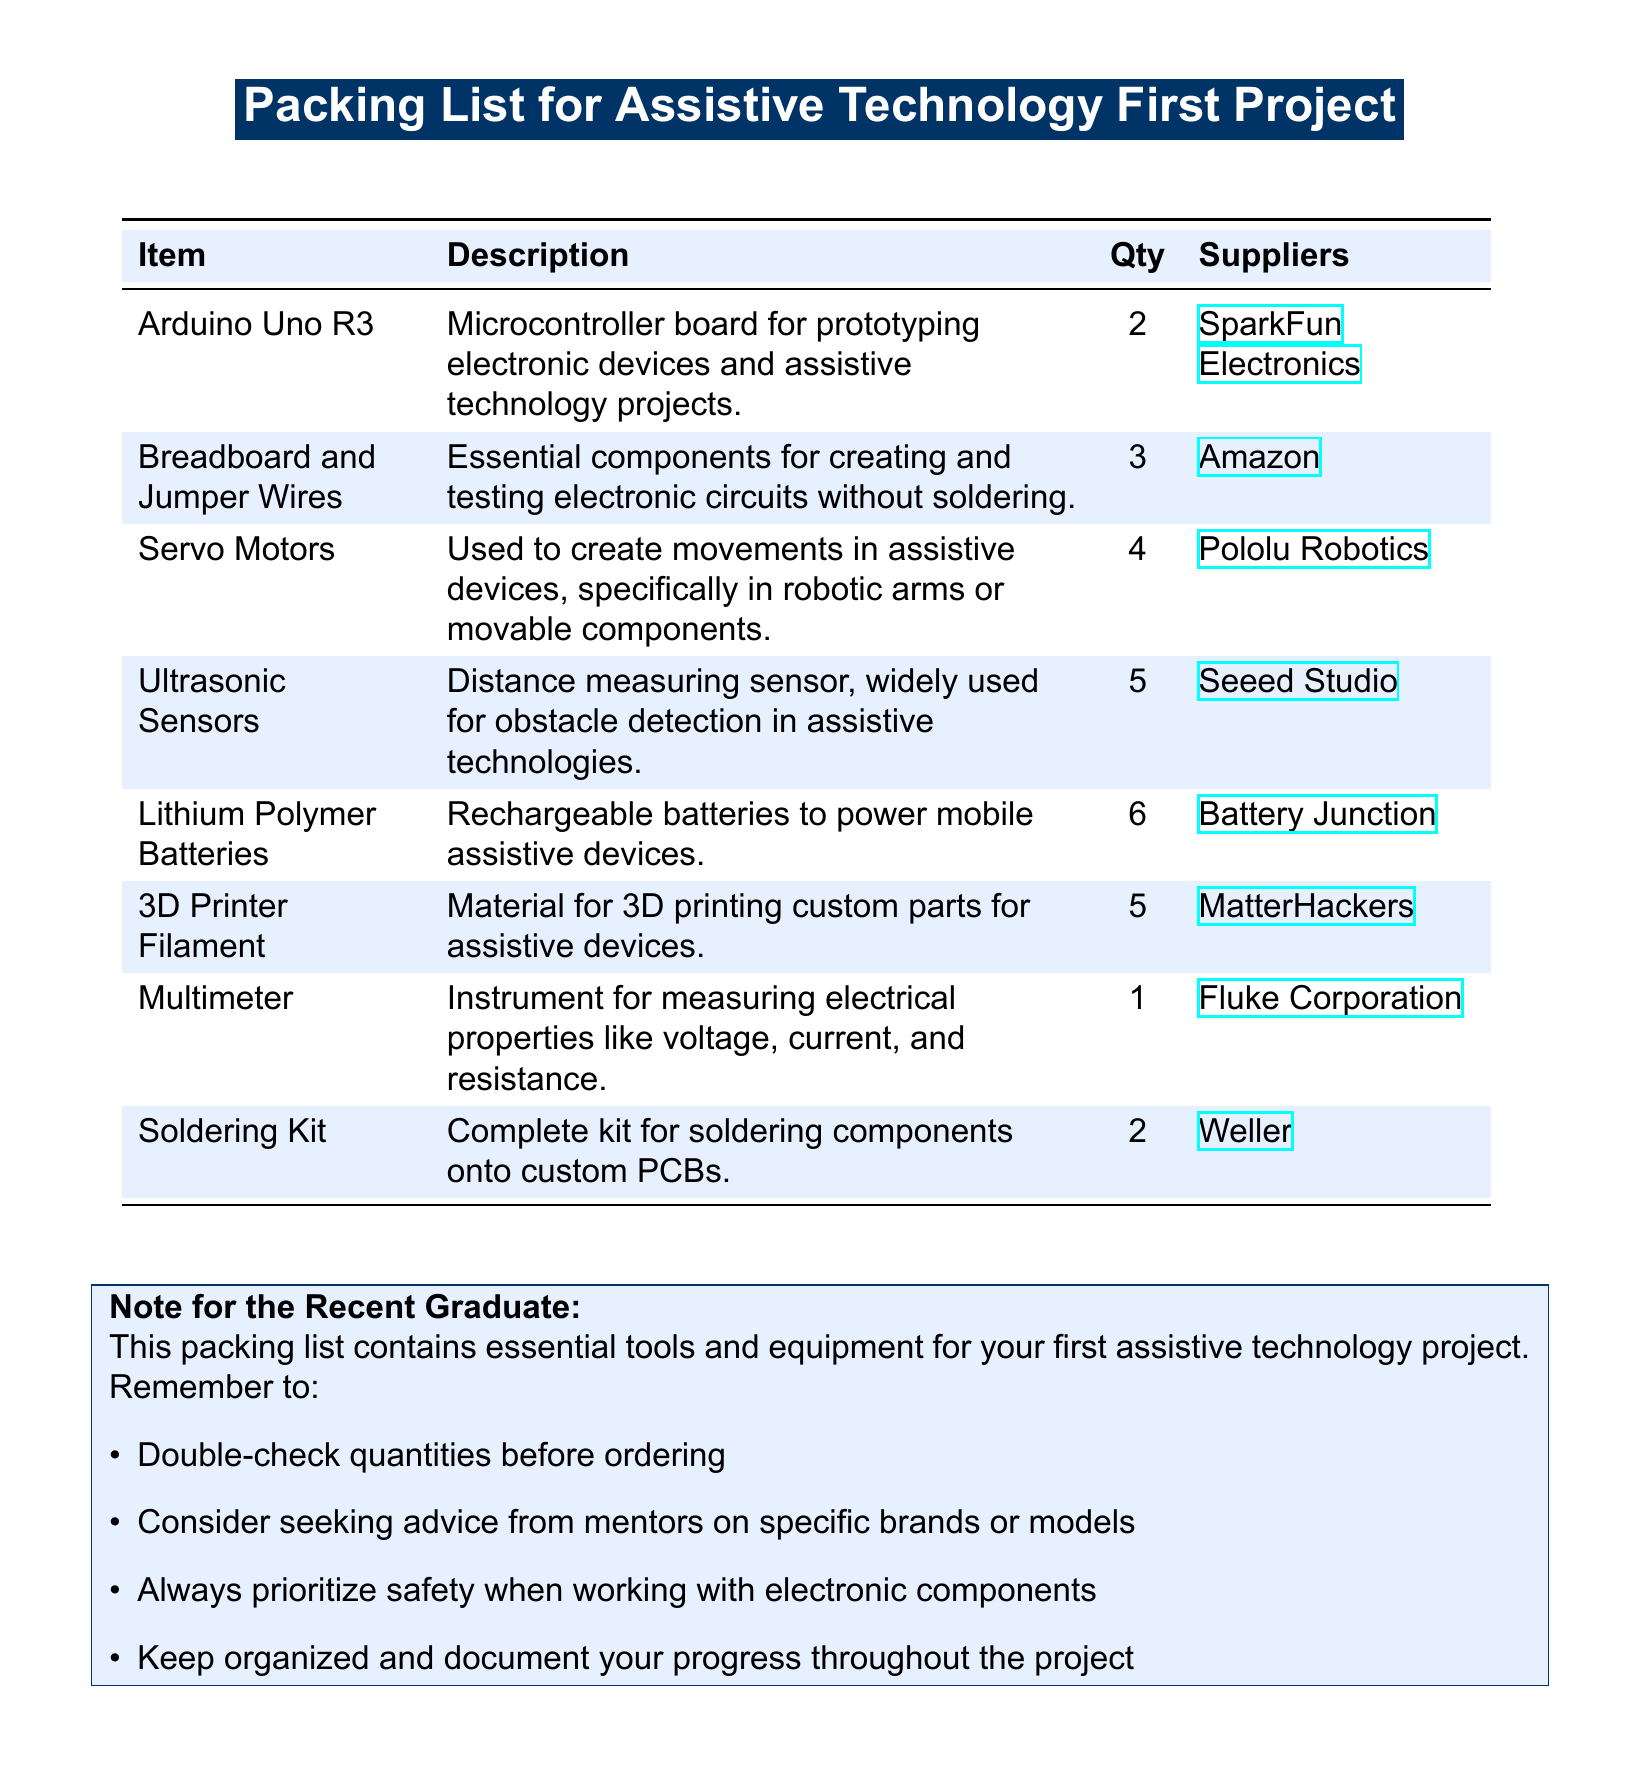What is the first item listed? The first item listed in the packing list is mentioned in the table at the top.
Answer: Arduino Uno R3 How many servo motors are needed? The quantity of servo motors is specified in the table.
Answer: 4 Which supplier provides the Ultrasonic Sensors? The supplier for Ultrasonic Sensors is listed directly in the relevant row of the table.
Answer: Seeed Studio What is the quantity of Lithium Polymer Batteries listed? The quantity for Lithium Polymer Batteries is directly given in the packing list table.
Answer: 6 What type of kit is included for soldering? The specific type of kit is found in the description column of the packing list.
Answer: Soldering Kit How many essential items are listed in total? The total number of items can be counted from the rows in the packing list.
Answer: 8 What is the primary use of 3D Printer Filament? The use of 3D Printer Filament is described in the respective row of the table.
Answer: Material for 3D printing custom parts What advice is suggested for ordering quantities? Specific instructions regarding ordering quantities are provided in the note section below the table.
Answer: Double-check quantities before ordering Which tool measures electrical properties? The tool measuring electrical properties is identified in the packing list.
Answer: Multimeter What color is used for alternate rows in the table? The color used for alternate rows is described in how the document is structured.
Answer: Light blue 